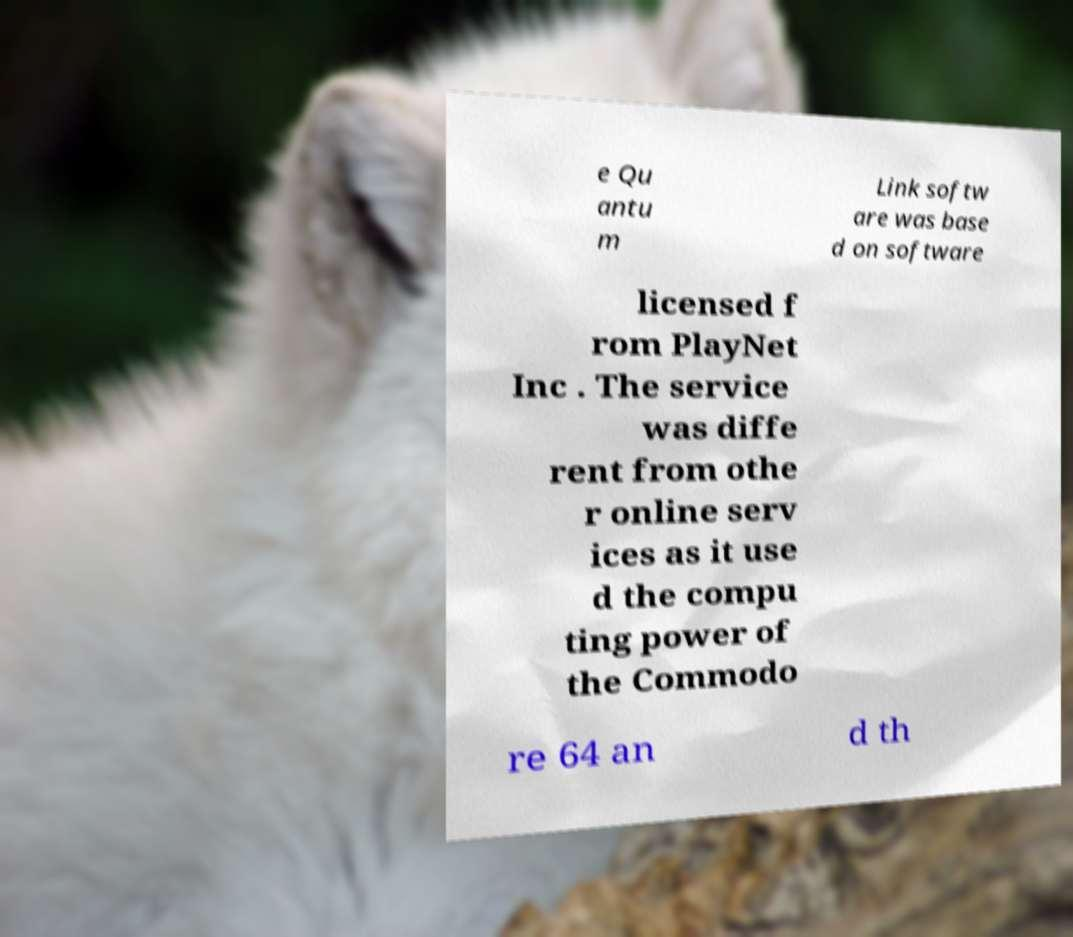Please identify and transcribe the text found in this image. e Qu antu m Link softw are was base d on software licensed f rom PlayNet Inc . The service was diffe rent from othe r online serv ices as it use d the compu ting power of the Commodo re 64 an d th 